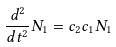<formula> <loc_0><loc_0><loc_500><loc_500>\frac { d ^ { 2 } } { d t ^ { 2 } } N _ { 1 } = c _ { 2 } c _ { 1 } N _ { 1 }</formula> 